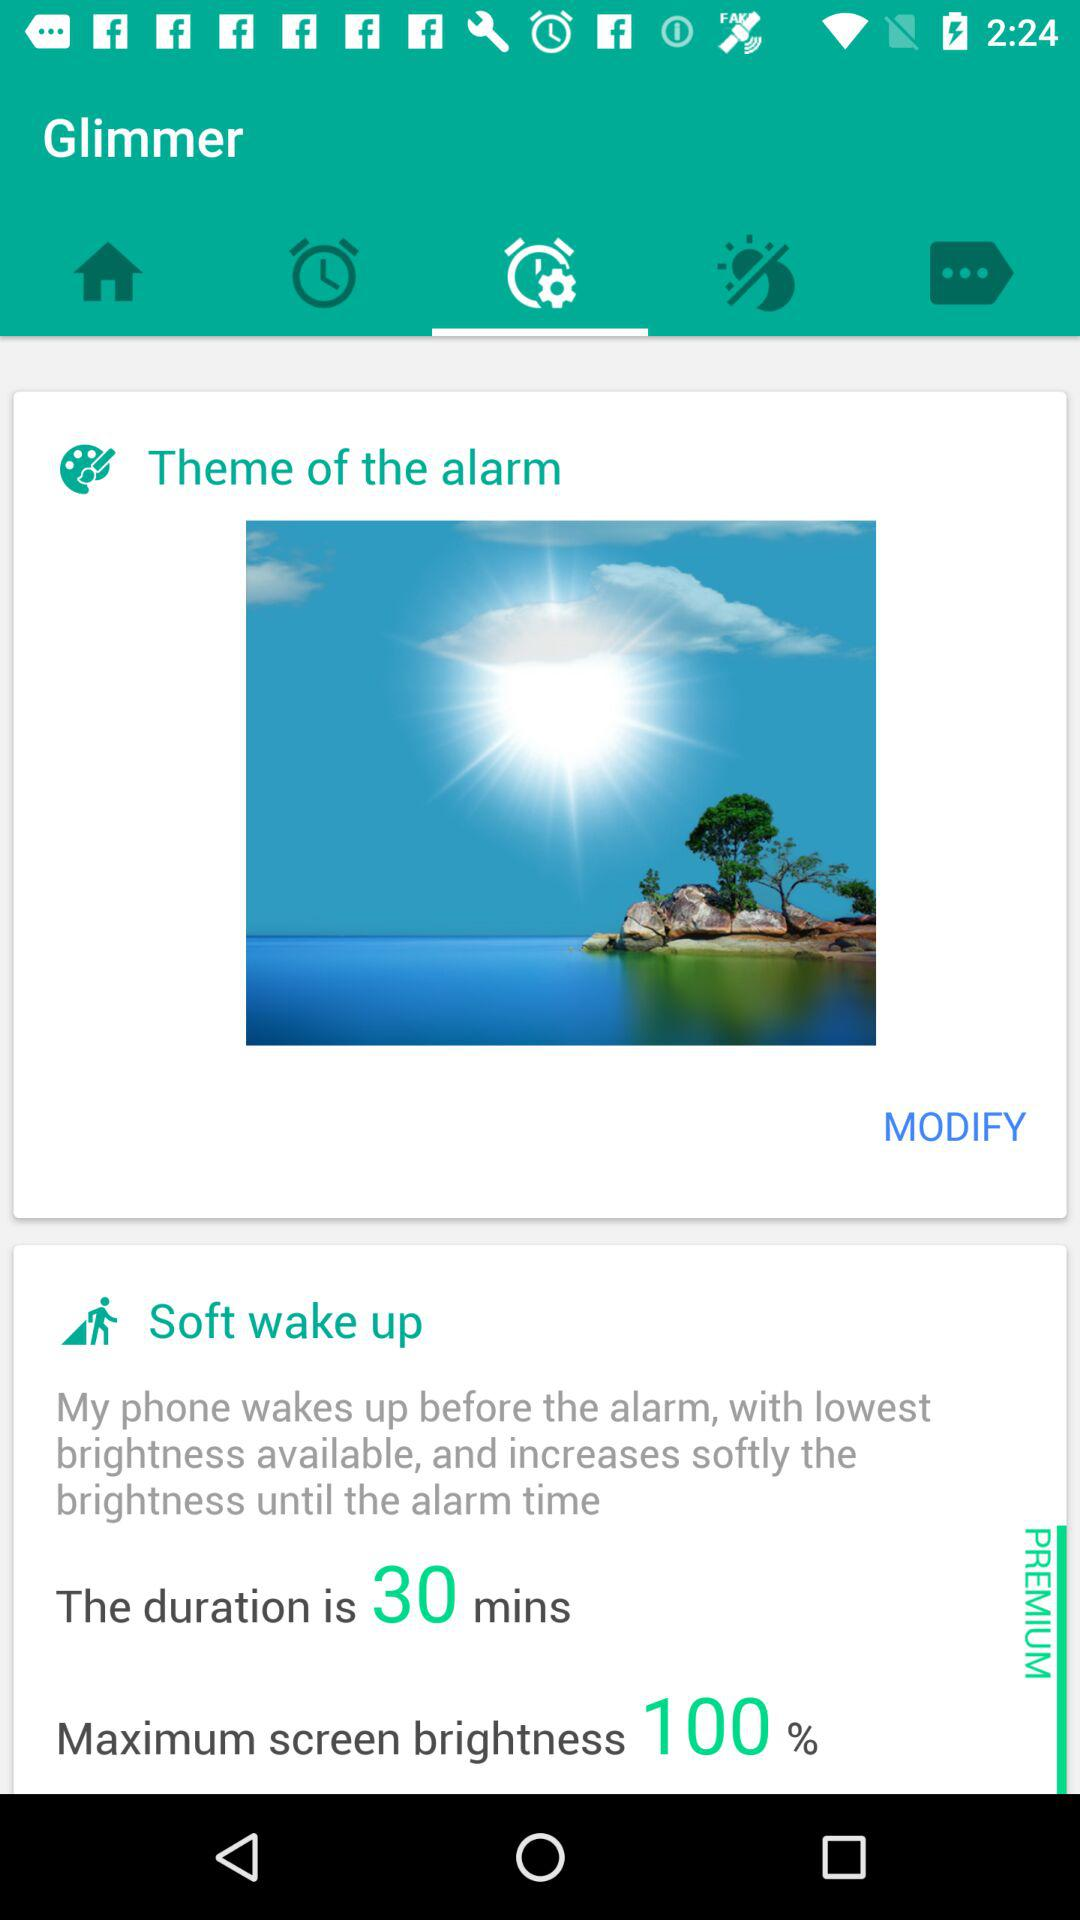Which tab is selected?
When the provided information is insufficient, respond with <no answer>. <no answer> 